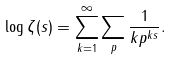Convert formula to latex. <formula><loc_0><loc_0><loc_500><loc_500>\log \zeta ( s ) = \sum _ { k = 1 } ^ { \infty } \sum _ { p } \frac { 1 } { k p ^ { k s } } .</formula> 